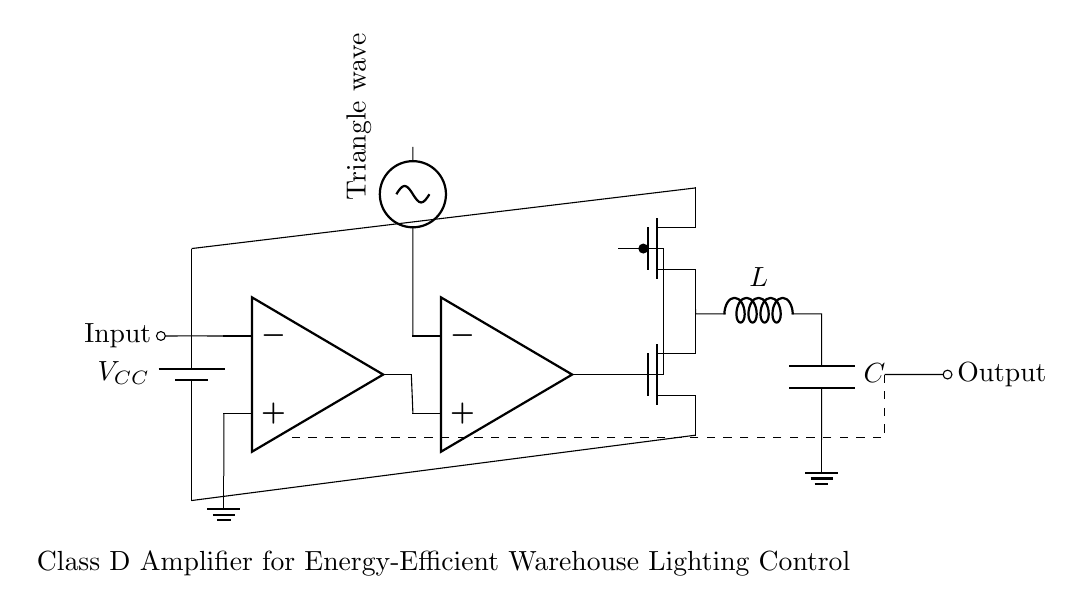What is the power supply voltage in this circuit? The power supply voltage can be found labeled in the diagram near the battery symbol, which is marked as VCC. The exact value is not provided in the schematic, but it indicates the voltage supplied to the circuit.
Answer: VCC What type of signal does the comparator receive? The comparator receives a triangle wave signal, which is indicated by the label next to the sinusoidal voltage source. This input is essential for determining the output switching of the amplifying stages.
Answer: Triangle wave How many operational amplifiers are present in the circuit? By counting the op-amp symbols in the diagram, we can see that there are two operational amplifiers depicted, one at the input stage and one as a comparator.
Answer: Two What is the purpose of the inductor in the output stage? The inductor in the output stage serves to filter the switching frequency from the Class D amplifier output, smoothing the pulse-width modulated signal into a more continuous current for the lighting load. This action helps to reduce electromagnetic interference and improve efficiency.
Answer: Filtering What are the types of transistors used in the driver stage? The driver stage utilizes an N-channel MOSFET and a P-channel MOSFET, as identified by the labels in the circuit diagram. These components work together to switch the load in response to the comparator's output and the input signal.
Answer: N-channel and P-channel MOSFETs What does the feedback path in the circuit achieve? The feedback path connects the output back to the input stage, which serves to stabilize the amplifier’s gain and improve linearity. This arrangement allows the circuit to adjust based on the output conditions, enhancing performance for lighting control.
Answer: Stability 